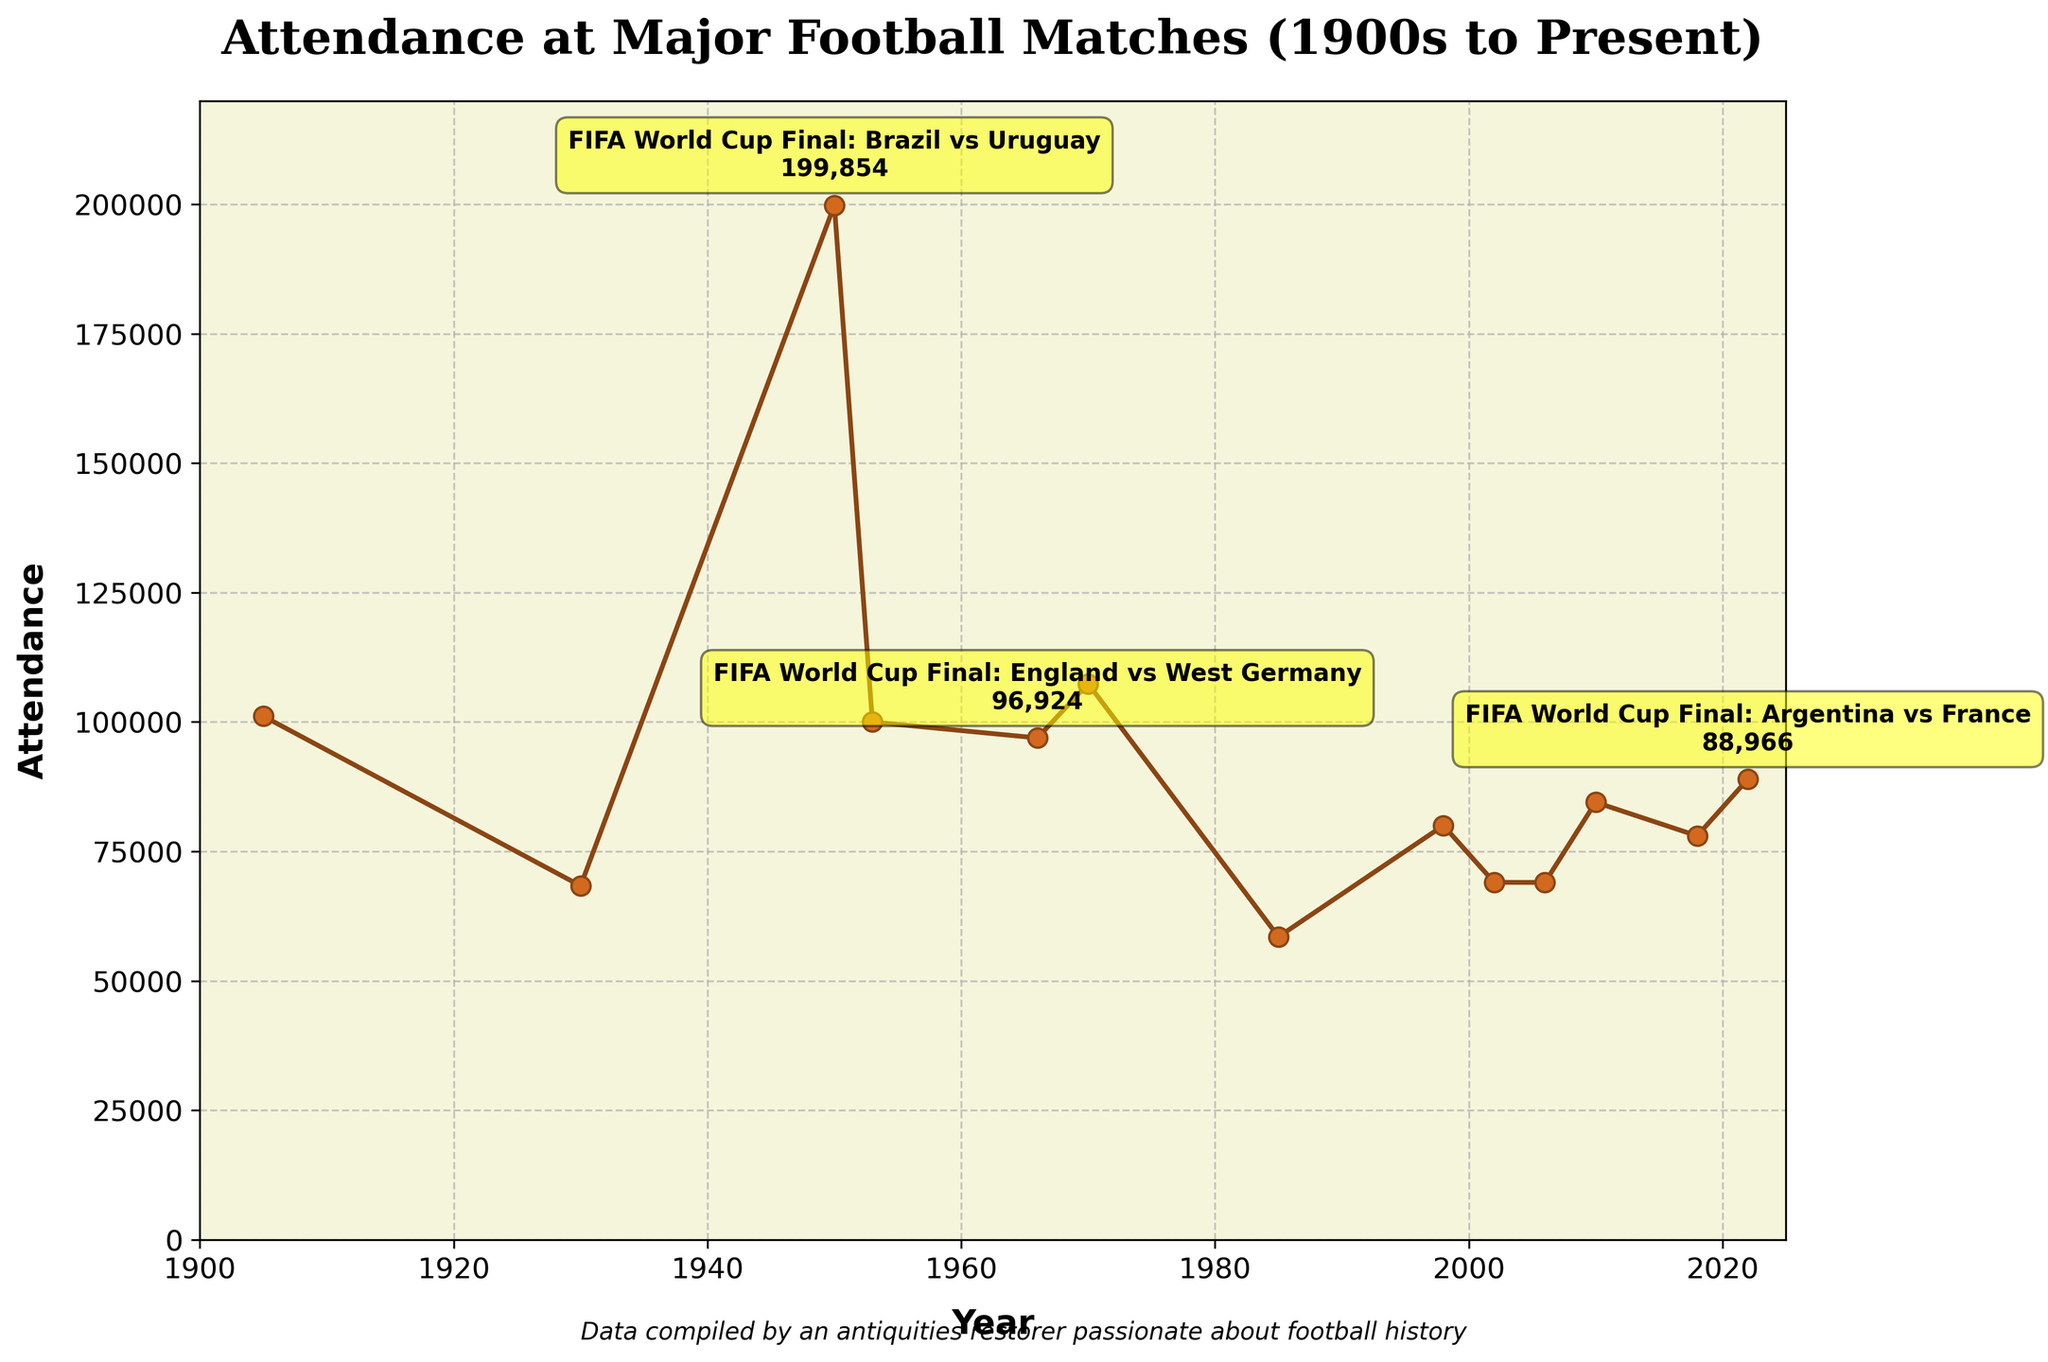What's the title of the plot? The title is usually located at the top of the figure and provides an overview of what the plot represents. Here, it is prominently displayed.
Answer: Attendance at Major Football Matches (1900s to Present) How many key points are annotated on the plot? To determine this, look for the points on the plot that have additional text annotations highlighting specific matches. There are three such points.
Answer: 3 What match in 1950 had the highest attendance, and what was the attendance number? Identify the point on the plot corresponding to the year 1950. The annotation next to this point will provide the match info and attendance.
Answer: FIFA World Cup Final: Brazil vs Uruguay, 199854 What is the range of years covered in the plot? By examining the x-axis, you can see the starting and ending points of the plot’s timeline. The plot begins from the early 1900s and extends to 2025.
Answer: 1900 to 2025 What is the lowest attendance recorded on this plot, and for which match did it occur? Look for the lowest point on the y-axis and identify the corresponding match from the plot. The lowest attendance noted here is 58500.
Answer: European Cup Final: Juventus vs Liverpool, 58500 Compare the attendance of the 1966 and 2022 FIFA World Cup Finals. Which one had higher attendance, and what are the numbers? Locate the points for 1966 and 2022 on the plot. The annotations or positions on the y-axis will indicate the attendance figures, which are 96924 and 88966, respectively.
Answer: 1966 had higher attendance, 96924 vs 88966 What is the average attendance of the FIFA World Cup Finals listed in this plot? To find the average, sum up all the attendance figures of the World Cup Finals and divide by the number of these matches. The relevant years are 1930, 1950, 1966, 1970, 1998, 2002, 2006, 2010, 2018, and 2022.
Answer: 89337.2 How many FIFA World Cup Finals are represented in the figure? By examining the annotations and labels on the plot, count how many matches are FIFA World Cup Finals. The plot shows ten FIFA World Cup Finals.
Answer: 10 What was the attendance for the FA Cup Final: Aston Villa vs Newcastle United in 1905? Locate the earliest point on the x-axis labeled with a match name, which corresponds to the year 1905. The attendance is indicated next to the point.
Answer: 101117 What is the trend in attendance over the years? By observing the plot, determine whether the general attendance at major football matches is increasing, decreasing, or fluctuating over time. The trend shows fluctuating attendance but generally remains high over the years.
Answer: Fluctuating 